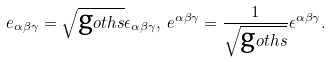<formula> <loc_0><loc_0><loc_500><loc_500>e _ { \alpha \beta \gamma } = \sqrt { \text  goth{s} } \epsilon _ { \alpha \beta \gamma } , \, e ^ { \alpha \beta \gamma } = \frac { 1 } { \sqrt { \text  goth{s} } } \epsilon ^ { \alpha \beta \gamma } .</formula> 